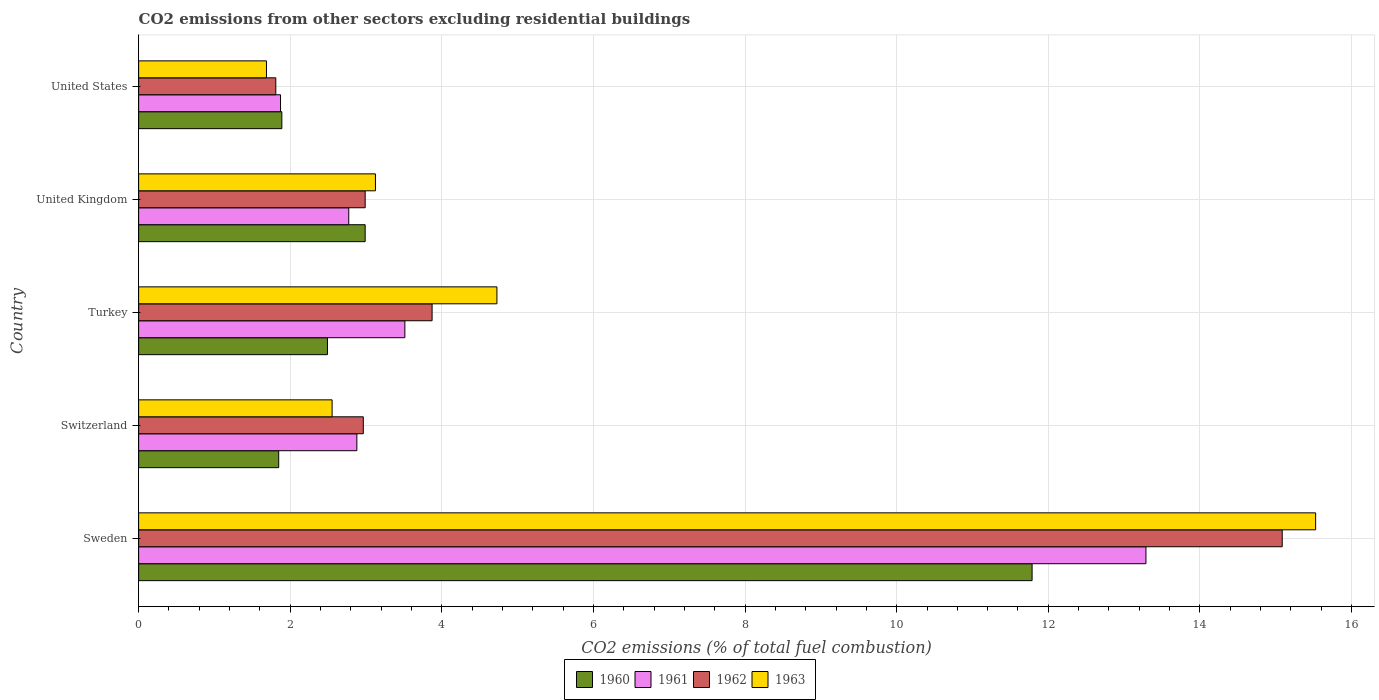How many different coloured bars are there?
Offer a terse response. 4. How many bars are there on the 3rd tick from the top?
Keep it short and to the point. 4. What is the label of the 4th group of bars from the top?
Your answer should be compact. Switzerland. What is the total CO2 emitted in 1961 in Switzerland?
Give a very brief answer. 2.88. Across all countries, what is the maximum total CO2 emitted in 1961?
Make the answer very short. 13.29. Across all countries, what is the minimum total CO2 emitted in 1961?
Provide a succinct answer. 1.87. What is the total total CO2 emitted in 1961 in the graph?
Offer a very short reply. 24.32. What is the difference between the total CO2 emitted in 1962 in Switzerland and that in United Kingdom?
Your answer should be very brief. -0.02. What is the difference between the total CO2 emitted in 1961 in United States and the total CO2 emitted in 1963 in Sweden?
Your answer should be compact. -13.65. What is the average total CO2 emitted in 1962 per country?
Keep it short and to the point. 5.34. What is the difference between the total CO2 emitted in 1960 and total CO2 emitted in 1961 in United States?
Your answer should be compact. 0.02. What is the ratio of the total CO2 emitted in 1963 in Switzerland to that in Turkey?
Give a very brief answer. 0.54. Is the total CO2 emitted in 1962 in Switzerland less than that in United States?
Your response must be concise. No. What is the difference between the highest and the second highest total CO2 emitted in 1963?
Offer a very short reply. 10.8. What is the difference between the highest and the lowest total CO2 emitted in 1963?
Your answer should be compact. 13.84. In how many countries, is the total CO2 emitted in 1962 greater than the average total CO2 emitted in 1962 taken over all countries?
Give a very brief answer. 1. Is it the case that in every country, the sum of the total CO2 emitted in 1962 and total CO2 emitted in 1963 is greater than the sum of total CO2 emitted in 1961 and total CO2 emitted in 1960?
Your answer should be very brief. No. What does the 4th bar from the top in Turkey represents?
Give a very brief answer. 1960. What does the 1st bar from the bottom in United States represents?
Offer a very short reply. 1960. How many bars are there?
Provide a succinct answer. 20. What is the difference between two consecutive major ticks on the X-axis?
Your answer should be very brief. 2. Are the values on the major ticks of X-axis written in scientific E-notation?
Give a very brief answer. No. Does the graph contain any zero values?
Provide a short and direct response. No. Where does the legend appear in the graph?
Give a very brief answer. Bottom center. How many legend labels are there?
Keep it short and to the point. 4. What is the title of the graph?
Offer a terse response. CO2 emissions from other sectors excluding residential buildings. What is the label or title of the X-axis?
Offer a terse response. CO2 emissions (% of total fuel combustion). What is the CO2 emissions (% of total fuel combustion) in 1960 in Sweden?
Your response must be concise. 11.79. What is the CO2 emissions (% of total fuel combustion) of 1961 in Sweden?
Offer a very short reply. 13.29. What is the CO2 emissions (% of total fuel combustion) in 1962 in Sweden?
Make the answer very short. 15.09. What is the CO2 emissions (% of total fuel combustion) in 1963 in Sweden?
Give a very brief answer. 15.53. What is the CO2 emissions (% of total fuel combustion) of 1960 in Switzerland?
Ensure brevity in your answer.  1.85. What is the CO2 emissions (% of total fuel combustion) of 1961 in Switzerland?
Provide a succinct answer. 2.88. What is the CO2 emissions (% of total fuel combustion) in 1962 in Switzerland?
Provide a succinct answer. 2.96. What is the CO2 emissions (% of total fuel combustion) in 1963 in Switzerland?
Provide a succinct answer. 2.55. What is the CO2 emissions (% of total fuel combustion) of 1960 in Turkey?
Ensure brevity in your answer.  2.49. What is the CO2 emissions (% of total fuel combustion) in 1961 in Turkey?
Provide a succinct answer. 3.51. What is the CO2 emissions (% of total fuel combustion) in 1962 in Turkey?
Offer a terse response. 3.87. What is the CO2 emissions (% of total fuel combustion) of 1963 in Turkey?
Provide a succinct answer. 4.73. What is the CO2 emissions (% of total fuel combustion) in 1960 in United Kingdom?
Ensure brevity in your answer.  2.99. What is the CO2 emissions (% of total fuel combustion) of 1961 in United Kingdom?
Offer a terse response. 2.77. What is the CO2 emissions (% of total fuel combustion) of 1962 in United Kingdom?
Provide a short and direct response. 2.99. What is the CO2 emissions (% of total fuel combustion) in 1963 in United Kingdom?
Provide a short and direct response. 3.12. What is the CO2 emissions (% of total fuel combustion) in 1960 in United States?
Keep it short and to the point. 1.89. What is the CO2 emissions (% of total fuel combustion) of 1961 in United States?
Your answer should be very brief. 1.87. What is the CO2 emissions (% of total fuel combustion) in 1962 in United States?
Offer a terse response. 1.81. What is the CO2 emissions (% of total fuel combustion) of 1963 in United States?
Ensure brevity in your answer.  1.69. Across all countries, what is the maximum CO2 emissions (% of total fuel combustion) in 1960?
Your answer should be very brief. 11.79. Across all countries, what is the maximum CO2 emissions (% of total fuel combustion) in 1961?
Offer a very short reply. 13.29. Across all countries, what is the maximum CO2 emissions (% of total fuel combustion) of 1962?
Your answer should be compact. 15.09. Across all countries, what is the maximum CO2 emissions (% of total fuel combustion) of 1963?
Your answer should be compact. 15.53. Across all countries, what is the minimum CO2 emissions (% of total fuel combustion) of 1960?
Give a very brief answer. 1.85. Across all countries, what is the minimum CO2 emissions (% of total fuel combustion) in 1961?
Give a very brief answer. 1.87. Across all countries, what is the minimum CO2 emissions (% of total fuel combustion) of 1962?
Keep it short and to the point. 1.81. Across all countries, what is the minimum CO2 emissions (% of total fuel combustion) of 1963?
Ensure brevity in your answer.  1.69. What is the total CO2 emissions (% of total fuel combustion) of 1960 in the graph?
Ensure brevity in your answer.  21. What is the total CO2 emissions (% of total fuel combustion) in 1961 in the graph?
Offer a very short reply. 24.32. What is the total CO2 emissions (% of total fuel combustion) in 1962 in the graph?
Your answer should be compact. 26.72. What is the total CO2 emissions (% of total fuel combustion) in 1963 in the graph?
Your answer should be compact. 27.62. What is the difference between the CO2 emissions (% of total fuel combustion) in 1960 in Sweden and that in Switzerland?
Provide a succinct answer. 9.94. What is the difference between the CO2 emissions (% of total fuel combustion) in 1961 in Sweden and that in Switzerland?
Your answer should be very brief. 10.41. What is the difference between the CO2 emissions (% of total fuel combustion) in 1962 in Sweden and that in Switzerland?
Provide a succinct answer. 12.12. What is the difference between the CO2 emissions (% of total fuel combustion) in 1963 in Sweden and that in Switzerland?
Offer a very short reply. 12.97. What is the difference between the CO2 emissions (% of total fuel combustion) in 1960 in Sweden and that in Turkey?
Ensure brevity in your answer.  9.3. What is the difference between the CO2 emissions (% of total fuel combustion) of 1961 in Sweden and that in Turkey?
Offer a terse response. 9.78. What is the difference between the CO2 emissions (% of total fuel combustion) of 1962 in Sweden and that in Turkey?
Your answer should be compact. 11.21. What is the difference between the CO2 emissions (% of total fuel combustion) in 1963 in Sweden and that in Turkey?
Ensure brevity in your answer.  10.8. What is the difference between the CO2 emissions (% of total fuel combustion) of 1960 in Sweden and that in United Kingdom?
Provide a succinct answer. 8.8. What is the difference between the CO2 emissions (% of total fuel combustion) in 1961 in Sweden and that in United Kingdom?
Ensure brevity in your answer.  10.52. What is the difference between the CO2 emissions (% of total fuel combustion) of 1962 in Sweden and that in United Kingdom?
Your answer should be very brief. 12.1. What is the difference between the CO2 emissions (% of total fuel combustion) of 1963 in Sweden and that in United Kingdom?
Make the answer very short. 12.4. What is the difference between the CO2 emissions (% of total fuel combustion) of 1960 in Sweden and that in United States?
Give a very brief answer. 9.9. What is the difference between the CO2 emissions (% of total fuel combustion) of 1961 in Sweden and that in United States?
Give a very brief answer. 11.42. What is the difference between the CO2 emissions (% of total fuel combustion) of 1962 in Sweden and that in United States?
Provide a succinct answer. 13.28. What is the difference between the CO2 emissions (% of total fuel combustion) of 1963 in Sweden and that in United States?
Ensure brevity in your answer.  13.84. What is the difference between the CO2 emissions (% of total fuel combustion) of 1960 in Switzerland and that in Turkey?
Offer a very short reply. -0.64. What is the difference between the CO2 emissions (% of total fuel combustion) of 1961 in Switzerland and that in Turkey?
Provide a short and direct response. -0.63. What is the difference between the CO2 emissions (% of total fuel combustion) in 1962 in Switzerland and that in Turkey?
Your response must be concise. -0.91. What is the difference between the CO2 emissions (% of total fuel combustion) in 1963 in Switzerland and that in Turkey?
Your answer should be very brief. -2.17. What is the difference between the CO2 emissions (% of total fuel combustion) in 1960 in Switzerland and that in United Kingdom?
Your response must be concise. -1.14. What is the difference between the CO2 emissions (% of total fuel combustion) of 1961 in Switzerland and that in United Kingdom?
Keep it short and to the point. 0.11. What is the difference between the CO2 emissions (% of total fuel combustion) of 1962 in Switzerland and that in United Kingdom?
Give a very brief answer. -0.02. What is the difference between the CO2 emissions (% of total fuel combustion) in 1963 in Switzerland and that in United Kingdom?
Provide a short and direct response. -0.57. What is the difference between the CO2 emissions (% of total fuel combustion) in 1960 in Switzerland and that in United States?
Provide a short and direct response. -0.04. What is the difference between the CO2 emissions (% of total fuel combustion) in 1962 in Switzerland and that in United States?
Make the answer very short. 1.15. What is the difference between the CO2 emissions (% of total fuel combustion) of 1963 in Switzerland and that in United States?
Offer a very short reply. 0.87. What is the difference between the CO2 emissions (% of total fuel combustion) of 1960 in Turkey and that in United Kingdom?
Keep it short and to the point. -0.5. What is the difference between the CO2 emissions (% of total fuel combustion) in 1961 in Turkey and that in United Kingdom?
Offer a terse response. 0.74. What is the difference between the CO2 emissions (% of total fuel combustion) in 1962 in Turkey and that in United Kingdom?
Offer a very short reply. 0.88. What is the difference between the CO2 emissions (% of total fuel combustion) of 1963 in Turkey and that in United Kingdom?
Your answer should be very brief. 1.6. What is the difference between the CO2 emissions (% of total fuel combustion) in 1960 in Turkey and that in United States?
Your answer should be compact. 0.6. What is the difference between the CO2 emissions (% of total fuel combustion) in 1961 in Turkey and that in United States?
Offer a terse response. 1.64. What is the difference between the CO2 emissions (% of total fuel combustion) of 1962 in Turkey and that in United States?
Keep it short and to the point. 2.06. What is the difference between the CO2 emissions (% of total fuel combustion) in 1963 in Turkey and that in United States?
Offer a very short reply. 3.04. What is the difference between the CO2 emissions (% of total fuel combustion) of 1960 in United Kingdom and that in United States?
Offer a terse response. 1.1. What is the difference between the CO2 emissions (% of total fuel combustion) in 1961 in United Kingdom and that in United States?
Offer a very short reply. 0.9. What is the difference between the CO2 emissions (% of total fuel combustion) of 1962 in United Kingdom and that in United States?
Offer a terse response. 1.18. What is the difference between the CO2 emissions (% of total fuel combustion) in 1963 in United Kingdom and that in United States?
Give a very brief answer. 1.44. What is the difference between the CO2 emissions (% of total fuel combustion) in 1960 in Sweden and the CO2 emissions (% of total fuel combustion) in 1961 in Switzerland?
Give a very brief answer. 8.91. What is the difference between the CO2 emissions (% of total fuel combustion) of 1960 in Sweden and the CO2 emissions (% of total fuel combustion) of 1962 in Switzerland?
Provide a short and direct response. 8.82. What is the difference between the CO2 emissions (% of total fuel combustion) of 1960 in Sweden and the CO2 emissions (% of total fuel combustion) of 1963 in Switzerland?
Make the answer very short. 9.23. What is the difference between the CO2 emissions (% of total fuel combustion) of 1961 in Sweden and the CO2 emissions (% of total fuel combustion) of 1962 in Switzerland?
Your answer should be very brief. 10.32. What is the difference between the CO2 emissions (% of total fuel combustion) of 1961 in Sweden and the CO2 emissions (% of total fuel combustion) of 1963 in Switzerland?
Your answer should be compact. 10.74. What is the difference between the CO2 emissions (% of total fuel combustion) of 1962 in Sweden and the CO2 emissions (% of total fuel combustion) of 1963 in Switzerland?
Keep it short and to the point. 12.53. What is the difference between the CO2 emissions (% of total fuel combustion) in 1960 in Sweden and the CO2 emissions (% of total fuel combustion) in 1961 in Turkey?
Your answer should be compact. 8.27. What is the difference between the CO2 emissions (% of total fuel combustion) of 1960 in Sweden and the CO2 emissions (% of total fuel combustion) of 1962 in Turkey?
Ensure brevity in your answer.  7.91. What is the difference between the CO2 emissions (% of total fuel combustion) of 1960 in Sweden and the CO2 emissions (% of total fuel combustion) of 1963 in Turkey?
Give a very brief answer. 7.06. What is the difference between the CO2 emissions (% of total fuel combustion) of 1961 in Sweden and the CO2 emissions (% of total fuel combustion) of 1962 in Turkey?
Provide a short and direct response. 9.42. What is the difference between the CO2 emissions (% of total fuel combustion) of 1961 in Sweden and the CO2 emissions (% of total fuel combustion) of 1963 in Turkey?
Your response must be concise. 8.56. What is the difference between the CO2 emissions (% of total fuel combustion) of 1962 in Sweden and the CO2 emissions (% of total fuel combustion) of 1963 in Turkey?
Ensure brevity in your answer.  10.36. What is the difference between the CO2 emissions (% of total fuel combustion) in 1960 in Sweden and the CO2 emissions (% of total fuel combustion) in 1961 in United Kingdom?
Offer a very short reply. 9.01. What is the difference between the CO2 emissions (% of total fuel combustion) in 1960 in Sweden and the CO2 emissions (% of total fuel combustion) in 1962 in United Kingdom?
Give a very brief answer. 8.8. What is the difference between the CO2 emissions (% of total fuel combustion) in 1960 in Sweden and the CO2 emissions (% of total fuel combustion) in 1963 in United Kingdom?
Offer a terse response. 8.66. What is the difference between the CO2 emissions (% of total fuel combustion) of 1961 in Sweden and the CO2 emissions (% of total fuel combustion) of 1962 in United Kingdom?
Keep it short and to the point. 10.3. What is the difference between the CO2 emissions (% of total fuel combustion) of 1961 in Sweden and the CO2 emissions (% of total fuel combustion) of 1963 in United Kingdom?
Your answer should be very brief. 10.16. What is the difference between the CO2 emissions (% of total fuel combustion) of 1962 in Sweden and the CO2 emissions (% of total fuel combustion) of 1963 in United Kingdom?
Ensure brevity in your answer.  11.96. What is the difference between the CO2 emissions (% of total fuel combustion) in 1960 in Sweden and the CO2 emissions (% of total fuel combustion) in 1961 in United States?
Offer a very short reply. 9.91. What is the difference between the CO2 emissions (% of total fuel combustion) of 1960 in Sweden and the CO2 emissions (% of total fuel combustion) of 1962 in United States?
Your response must be concise. 9.98. What is the difference between the CO2 emissions (% of total fuel combustion) of 1960 in Sweden and the CO2 emissions (% of total fuel combustion) of 1963 in United States?
Offer a terse response. 10.1. What is the difference between the CO2 emissions (% of total fuel combustion) in 1961 in Sweden and the CO2 emissions (% of total fuel combustion) in 1962 in United States?
Keep it short and to the point. 11.48. What is the difference between the CO2 emissions (% of total fuel combustion) in 1961 in Sweden and the CO2 emissions (% of total fuel combustion) in 1963 in United States?
Keep it short and to the point. 11.6. What is the difference between the CO2 emissions (% of total fuel combustion) in 1962 in Sweden and the CO2 emissions (% of total fuel combustion) in 1963 in United States?
Make the answer very short. 13.4. What is the difference between the CO2 emissions (% of total fuel combustion) of 1960 in Switzerland and the CO2 emissions (% of total fuel combustion) of 1961 in Turkey?
Provide a succinct answer. -1.66. What is the difference between the CO2 emissions (% of total fuel combustion) in 1960 in Switzerland and the CO2 emissions (% of total fuel combustion) in 1962 in Turkey?
Give a very brief answer. -2.02. What is the difference between the CO2 emissions (% of total fuel combustion) in 1960 in Switzerland and the CO2 emissions (% of total fuel combustion) in 1963 in Turkey?
Offer a very short reply. -2.88. What is the difference between the CO2 emissions (% of total fuel combustion) in 1961 in Switzerland and the CO2 emissions (% of total fuel combustion) in 1962 in Turkey?
Provide a succinct answer. -0.99. What is the difference between the CO2 emissions (% of total fuel combustion) in 1961 in Switzerland and the CO2 emissions (% of total fuel combustion) in 1963 in Turkey?
Your answer should be very brief. -1.85. What is the difference between the CO2 emissions (% of total fuel combustion) of 1962 in Switzerland and the CO2 emissions (% of total fuel combustion) of 1963 in Turkey?
Ensure brevity in your answer.  -1.76. What is the difference between the CO2 emissions (% of total fuel combustion) in 1960 in Switzerland and the CO2 emissions (% of total fuel combustion) in 1961 in United Kingdom?
Offer a terse response. -0.92. What is the difference between the CO2 emissions (% of total fuel combustion) in 1960 in Switzerland and the CO2 emissions (% of total fuel combustion) in 1962 in United Kingdom?
Your answer should be very brief. -1.14. What is the difference between the CO2 emissions (% of total fuel combustion) in 1960 in Switzerland and the CO2 emissions (% of total fuel combustion) in 1963 in United Kingdom?
Provide a short and direct response. -1.28. What is the difference between the CO2 emissions (% of total fuel combustion) of 1961 in Switzerland and the CO2 emissions (% of total fuel combustion) of 1962 in United Kingdom?
Your response must be concise. -0.11. What is the difference between the CO2 emissions (% of total fuel combustion) in 1961 in Switzerland and the CO2 emissions (% of total fuel combustion) in 1963 in United Kingdom?
Your answer should be compact. -0.25. What is the difference between the CO2 emissions (% of total fuel combustion) in 1962 in Switzerland and the CO2 emissions (% of total fuel combustion) in 1963 in United Kingdom?
Make the answer very short. -0.16. What is the difference between the CO2 emissions (% of total fuel combustion) of 1960 in Switzerland and the CO2 emissions (% of total fuel combustion) of 1961 in United States?
Provide a succinct answer. -0.02. What is the difference between the CO2 emissions (% of total fuel combustion) of 1960 in Switzerland and the CO2 emissions (% of total fuel combustion) of 1962 in United States?
Your answer should be very brief. 0.04. What is the difference between the CO2 emissions (% of total fuel combustion) in 1960 in Switzerland and the CO2 emissions (% of total fuel combustion) in 1963 in United States?
Provide a short and direct response. 0.16. What is the difference between the CO2 emissions (% of total fuel combustion) of 1961 in Switzerland and the CO2 emissions (% of total fuel combustion) of 1962 in United States?
Keep it short and to the point. 1.07. What is the difference between the CO2 emissions (% of total fuel combustion) of 1961 in Switzerland and the CO2 emissions (% of total fuel combustion) of 1963 in United States?
Make the answer very short. 1.19. What is the difference between the CO2 emissions (% of total fuel combustion) in 1962 in Switzerland and the CO2 emissions (% of total fuel combustion) in 1963 in United States?
Offer a very short reply. 1.28. What is the difference between the CO2 emissions (% of total fuel combustion) in 1960 in Turkey and the CO2 emissions (% of total fuel combustion) in 1961 in United Kingdom?
Your answer should be very brief. -0.28. What is the difference between the CO2 emissions (% of total fuel combustion) of 1960 in Turkey and the CO2 emissions (% of total fuel combustion) of 1962 in United Kingdom?
Make the answer very short. -0.5. What is the difference between the CO2 emissions (% of total fuel combustion) in 1960 in Turkey and the CO2 emissions (% of total fuel combustion) in 1963 in United Kingdom?
Offer a terse response. -0.63. What is the difference between the CO2 emissions (% of total fuel combustion) in 1961 in Turkey and the CO2 emissions (% of total fuel combustion) in 1962 in United Kingdom?
Offer a terse response. 0.52. What is the difference between the CO2 emissions (% of total fuel combustion) in 1961 in Turkey and the CO2 emissions (% of total fuel combustion) in 1963 in United Kingdom?
Keep it short and to the point. 0.39. What is the difference between the CO2 emissions (% of total fuel combustion) in 1962 in Turkey and the CO2 emissions (% of total fuel combustion) in 1963 in United Kingdom?
Offer a very short reply. 0.75. What is the difference between the CO2 emissions (% of total fuel combustion) in 1960 in Turkey and the CO2 emissions (% of total fuel combustion) in 1961 in United States?
Give a very brief answer. 0.62. What is the difference between the CO2 emissions (% of total fuel combustion) of 1960 in Turkey and the CO2 emissions (% of total fuel combustion) of 1962 in United States?
Your answer should be very brief. 0.68. What is the difference between the CO2 emissions (% of total fuel combustion) in 1960 in Turkey and the CO2 emissions (% of total fuel combustion) in 1963 in United States?
Make the answer very short. 0.8. What is the difference between the CO2 emissions (% of total fuel combustion) of 1961 in Turkey and the CO2 emissions (% of total fuel combustion) of 1962 in United States?
Provide a short and direct response. 1.7. What is the difference between the CO2 emissions (% of total fuel combustion) of 1961 in Turkey and the CO2 emissions (% of total fuel combustion) of 1963 in United States?
Provide a short and direct response. 1.83. What is the difference between the CO2 emissions (% of total fuel combustion) in 1962 in Turkey and the CO2 emissions (% of total fuel combustion) in 1963 in United States?
Provide a succinct answer. 2.18. What is the difference between the CO2 emissions (% of total fuel combustion) in 1960 in United Kingdom and the CO2 emissions (% of total fuel combustion) in 1961 in United States?
Offer a very short reply. 1.12. What is the difference between the CO2 emissions (% of total fuel combustion) in 1960 in United Kingdom and the CO2 emissions (% of total fuel combustion) in 1962 in United States?
Offer a very short reply. 1.18. What is the difference between the CO2 emissions (% of total fuel combustion) of 1960 in United Kingdom and the CO2 emissions (% of total fuel combustion) of 1963 in United States?
Provide a short and direct response. 1.3. What is the difference between the CO2 emissions (% of total fuel combustion) of 1961 in United Kingdom and the CO2 emissions (% of total fuel combustion) of 1962 in United States?
Keep it short and to the point. 0.96. What is the difference between the CO2 emissions (% of total fuel combustion) of 1961 in United Kingdom and the CO2 emissions (% of total fuel combustion) of 1963 in United States?
Your answer should be very brief. 1.09. What is the difference between the CO2 emissions (% of total fuel combustion) in 1962 in United Kingdom and the CO2 emissions (% of total fuel combustion) in 1963 in United States?
Your response must be concise. 1.3. What is the average CO2 emissions (% of total fuel combustion) of 1960 per country?
Offer a terse response. 4.2. What is the average CO2 emissions (% of total fuel combustion) of 1961 per country?
Offer a terse response. 4.86. What is the average CO2 emissions (% of total fuel combustion) in 1962 per country?
Make the answer very short. 5.34. What is the average CO2 emissions (% of total fuel combustion) in 1963 per country?
Ensure brevity in your answer.  5.52. What is the difference between the CO2 emissions (% of total fuel combustion) in 1960 and CO2 emissions (% of total fuel combustion) in 1961 in Sweden?
Make the answer very short. -1.5. What is the difference between the CO2 emissions (% of total fuel combustion) in 1960 and CO2 emissions (% of total fuel combustion) in 1962 in Sweden?
Offer a terse response. -3.3. What is the difference between the CO2 emissions (% of total fuel combustion) in 1960 and CO2 emissions (% of total fuel combustion) in 1963 in Sweden?
Offer a terse response. -3.74. What is the difference between the CO2 emissions (% of total fuel combustion) of 1961 and CO2 emissions (% of total fuel combustion) of 1962 in Sweden?
Ensure brevity in your answer.  -1.8. What is the difference between the CO2 emissions (% of total fuel combustion) in 1961 and CO2 emissions (% of total fuel combustion) in 1963 in Sweden?
Make the answer very short. -2.24. What is the difference between the CO2 emissions (% of total fuel combustion) of 1962 and CO2 emissions (% of total fuel combustion) of 1963 in Sweden?
Provide a short and direct response. -0.44. What is the difference between the CO2 emissions (% of total fuel combustion) in 1960 and CO2 emissions (% of total fuel combustion) in 1961 in Switzerland?
Offer a very short reply. -1.03. What is the difference between the CO2 emissions (% of total fuel combustion) in 1960 and CO2 emissions (% of total fuel combustion) in 1962 in Switzerland?
Give a very brief answer. -1.12. What is the difference between the CO2 emissions (% of total fuel combustion) of 1960 and CO2 emissions (% of total fuel combustion) of 1963 in Switzerland?
Offer a terse response. -0.7. What is the difference between the CO2 emissions (% of total fuel combustion) of 1961 and CO2 emissions (% of total fuel combustion) of 1962 in Switzerland?
Make the answer very short. -0.08. What is the difference between the CO2 emissions (% of total fuel combustion) of 1961 and CO2 emissions (% of total fuel combustion) of 1963 in Switzerland?
Offer a terse response. 0.33. What is the difference between the CO2 emissions (% of total fuel combustion) in 1962 and CO2 emissions (% of total fuel combustion) in 1963 in Switzerland?
Offer a very short reply. 0.41. What is the difference between the CO2 emissions (% of total fuel combustion) in 1960 and CO2 emissions (% of total fuel combustion) in 1961 in Turkey?
Offer a terse response. -1.02. What is the difference between the CO2 emissions (% of total fuel combustion) in 1960 and CO2 emissions (% of total fuel combustion) in 1962 in Turkey?
Your response must be concise. -1.38. What is the difference between the CO2 emissions (% of total fuel combustion) of 1960 and CO2 emissions (% of total fuel combustion) of 1963 in Turkey?
Provide a succinct answer. -2.24. What is the difference between the CO2 emissions (% of total fuel combustion) in 1961 and CO2 emissions (% of total fuel combustion) in 1962 in Turkey?
Offer a very short reply. -0.36. What is the difference between the CO2 emissions (% of total fuel combustion) of 1961 and CO2 emissions (% of total fuel combustion) of 1963 in Turkey?
Your answer should be very brief. -1.21. What is the difference between the CO2 emissions (% of total fuel combustion) in 1962 and CO2 emissions (% of total fuel combustion) in 1963 in Turkey?
Provide a short and direct response. -0.85. What is the difference between the CO2 emissions (% of total fuel combustion) in 1960 and CO2 emissions (% of total fuel combustion) in 1961 in United Kingdom?
Make the answer very short. 0.22. What is the difference between the CO2 emissions (% of total fuel combustion) in 1960 and CO2 emissions (% of total fuel combustion) in 1962 in United Kingdom?
Make the answer very short. -0. What is the difference between the CO2 emissions (% of total fuel combustion) of 1960 and CO2 emissions (% of total fuel combustion) of 1963 in United Kingdom?
Make the answer very short. -0.14. What is the difference between the CO2 emissions (% of total fuel combustion) of 1961 and CO2 emissions (% of total fuel combustion) of 1962 in United Kingdom?
Make the answer very short. -0.22. What is the difference between the CO2 emissions (% of total fuel combustion) in 1961 and CO2 emissions (% of total fuel combustion) in 1963 in United Kingdom?
Your answer should be compact. -0.35. What is the difference between the CO2 emissions (% of total fuel combustion) in 1962 and CO2 emissions (% of total fuel combustion) in 1963 in United Kingdom?
Give a very brief answer. -0.14. What is the difference between the CO2 emissions (% of total fuel combustion) in 1960 and CO2 emissions (% of total fuel combustion) in 1961 in United States?
Give a very brief answer. 0.02. What is the difference between the CO2 emissions (% of total fuel combustion) in 1960 and CO2 emissions (% of total fuel combustion) in 1962 in United States?
Provide a short and direct response. 0.08. What is the difference between the CO2 emissions (% of total fuel combustion) of 1960 and CO2 emissions (% of total fuel combustion) of 1963 in United States?
Give a very brief answer. 0.2. What is the difference between the CO2 emissions (% of total fuel combustion) in 1961 and CO2 emissions (% of total fuel combustion) in 1962 in United States?
Provide a succinct answer. 0.06. What is the difference between the CO2 emissions (% of total fuel combustion) of 1961 and CO2 emissions (% of total fuel combustion) of 1963 in United States?
Provide a short and direct response. 0.19. What is the difference between the CO2 emissions (% of total fuel combustion) of 1962 and CO2 emissions (% of total fuel combustion) of 1963 in United States?
Make the answer very short. 0.12. What is the ratio of the CO2 emissions (% of total fuel combustion) in 1960 in Sweden to that in Switzerland?
Keep it short and to the point. 6.38. What is the ratio of the CO2 emissions (% of total fuel combustion) of 1961 in Sweden to that in Switzerland?
Provide a short and direct response. 4.62. What is the ratio of the CO2 emissions (% of total fuel combustion) in 1962 in Sweden to that in Switzerland?
Provide a short and direct response. 5.09. What is the ratio of the CO2 emissions (% of total fuel combustion) in 1963 in Sweden to that in Switzerland?
Give a very brief answer. 6.08. What is the ratio of the CO2 emissions (% of total fuel combustion) of 1960 in Sweden to that in Turkey?
Give a very brief answer. 4.73. What is the ratio of the CO2 emissions (% of total fuel combustion) in 1961 in Sweden to that in Turkey?
Offer a very short reply. 3.78. What is the ratio of the CO2 emissions (% of total fuel combustion) in 1962 in Sweden to that in Turkey?
Offer a terse response. 3.9. What is the ratio of the CO2 emissions (% of total fuel combustion) of 1963 in Sweden to that in Turkey?
Ensure brevity in your answer.  3.29. What is the ratio of the CO2 emissions (% of total fuel combustion) of 1960 in Sweden to that in United Kingdom?
Provide a short and direct response. 3.94. What is the ratio of the CO2 emissions (% of total fuel combustion) of 1961 in Sweden to that in United Kingdom?
Provide a succinct answer. 4.79. What is the ratio of the CO2 emissions (% of total fuel combustion) in 1962 in Sweden to that in United Kingdom?
Your answer should be compact. 5.05. What is the ratio of the CO2 emissions (% of total fuel combustion) in 1963 in Sweden to that in United Kingdom?
Provide a succinct answer. 4.97. What is the ratio of the CO2 emissions (% of total fuel combustion) of 1960 in Sweden to that in United States?
Your answer should be compact. 6.24. What is the ratio of the CO2 emissions (% of total fuel combustion) of 1961 in Sweden to that in United States?
Give a very brief answer. 7.1. What is the ratio of the CO2 emissions (% of total fuel combustion) of 1962 in Sweden to that in United States?
Offer a very short reply. 8.34. What is the ratio of the CO2 emissions (% of total fuel combustion) of 1963 in Sweden to that in United States?
Offer a terse response. 9.21. What is the ratio of the CO2 emissions (% of total fuel combustion) of 1960 in Switzerland to that in Turkey?
Keep it short and to the point. 0.74. What is the ratio of the CO2 emissions (% of total fuel combustion) in 1961 in Switzerland to that in Turkey?
Your answer should be very brief. 0.82. What is the ratio of the CO2 emissions (% of total fuel combustion) of 1962 in Switzerland to that in Turkey?
Offer a very short reply. 0.77. What is the ratio of the CO2 emissions (% of total fuel combustion) in 1963 in Switzerland to that in Turkey?
Give a very brief answer. 0.54. What is the ratio of the CO2 emissions (% of total fuel combustion) of 1960 in Switzerland to that in United Kingdom?
Give a very brief answer. 0.62. What is the ratio of the CO2 emissions (% of total fuel combustion) of 1961 in Switzerland to that in United Kingdom?
Keep it short and to the point. 1.04. What is the ratio of the CO2 emissions (% of total fuel combustion) of 1963 in Switzerland to that in United Kingdom?
Provide a succinct answer. 0.82. What is the ratio of the CO2 emissions (% of total fuel combustion) of 1960 in Switzerland to that in United States?
Provide a short and direct response. 0.98. What is the ratio of the CO2 emissions (% of total fuel combustion) of 1961 in Switzerland to that in United States?
Provide a succinct answer. 1.54. What is the ratio of the CO2 emissions (% of total fuel combustion) in 1962 in Switzerland to that in United States?
Offer a very short reply. 1.64. What is the ratio of the CO2 emissions (% of total fuel combustion) in 1963 in Switzerland to that in United States?
Make the answer very short. 1.51. What is the ratio of the CO2 emissions (% of total fuel combustion) of 1960 in Turkey to that in United Kingdom?
Make the answer very short. 0.83. What is the ratio of the CO2 emissions (% of total fuel combustion) in 1961 in Turkey to that in United Kingdom?
Your answer should be compact. 1.27. What is the ratio of the CO2 emissions (% of total fuel combustion) of 1962 in Turkey to that in United Kingdom?
Keep it short and to the point. 1.3. What is the ratio of the CO2 emissions (% of total fuel combustion) in 1963 in Turkey to that in United Kingdom?
Provide a short and direct response. 1.51. What is the ratio of the CO2 emissions (% of total fuel combustion) in 1960 in Turkey to that in United States?
Offer a terse response. 1.32. What is the ratio of the CO2 emissions (% of total fuel combustion) in 1961 in Turkey to that in United States?
Offer a terse response. 1.88. What is the ratio of the CO2 emissions (% of total fuel combustion) of 1962 in Turkey to that in United States?
Your answer should be compact. 2.14. What is the ratio of the CO2 emissions (% of total fuel combustion) in 1963 in Turkey to that in United States?
Provide a succinct answer. 2.8. What is the ratio of the CO2 emissions (% of total fuel combustion) of 1960 in United Kingdom to that in United States?
Make the answer very short. 1.58. What is the ratio of the CO2 emissions (% of total fuel combustion) in 1961 in United Kingdom to that in United States?
Offer a terse response. 1.48. What is the ratio of the CO2 emissions (% of total fuel combustion) of 1962 in United Kingdom to that in United States?
Ensure brevity in your answer.  1.65. What is the ratio of the CO2 emissions (% of total fuel combustion) in 1963 in United Kingdom to that in United States?
Ensure brevity in your answer.  1.85. What is the difference between the highest and the second highest CO2 emissions (% of total fuel combustion) of 1960?
Keep it short and to the point. 8.8. What is the difference between the highest and the second highest CO2 emissions (% of total fuel combustion) of 1961?
Offer a very short reply. 9.78. What is the difference between the highest and the second highest CO2 emissions (% of total fuel combustion) in 1962?
Give a very brief answer. 11.21. What is the difference between the highest and the second highest CO2 emissions (% of total fuel combustion) in 1963?
Give a very brief answer. 10.8. What is the difference between the highest and the lowest CO2 emissions (% of total fuel combustion) in 1960?
Your response must be concise. 9.94. What is the difference between the highest and the lowest CO2 emissions (% of total fuel combustion) of 1961?
Offer a very short reply. 11.42. What is the difference between the highest and the lowest CO2 emissions (% of total fuel combustion) of 1962?
Your answer should be compact. 13.28. What is the difference between the highest and the lowest CO2 emissions (% of total fuel combustion) in 1963?
Offer a very short reply. 13.84. 